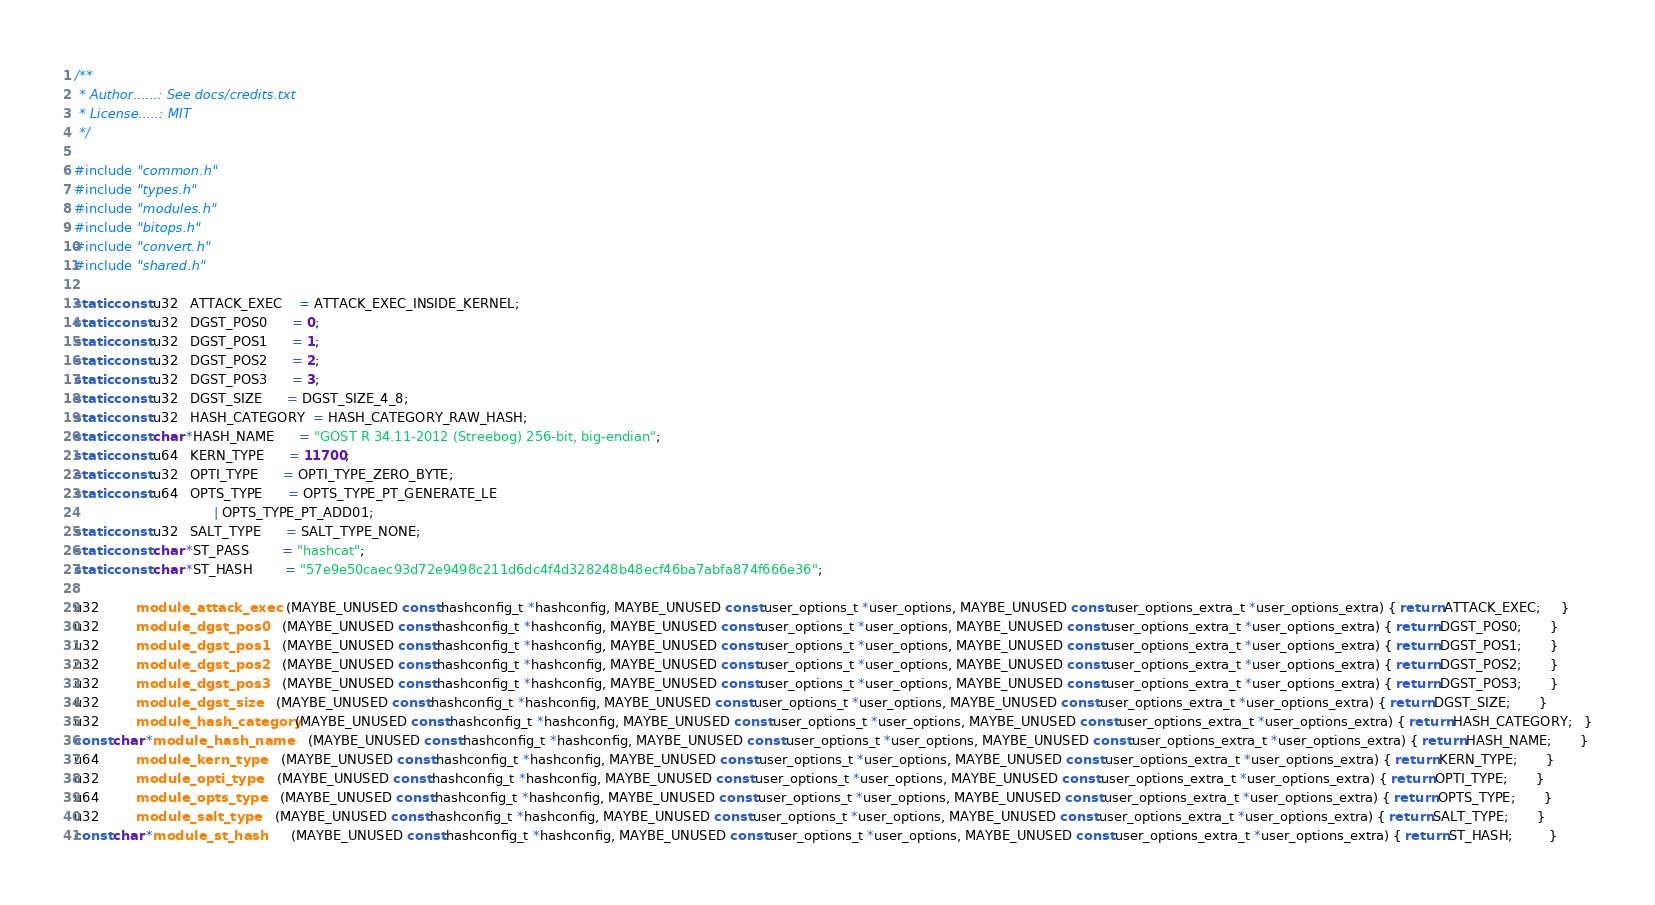Convert code to text. <code><loc_0><loc_0><loc_500><loc_500><_C_>/**
 * Author......: See docs/credits.txt
 * License.....: MIT
 */

#include "common.h"
#include "types.h"
#include "modules.h"
#include "bitops.h"
#include "convert.h"
#include "shared.h"

static const u32   ATTACK_EXEC    = ATTACK_EXEC_INSIDE_KERNEL;
static const u32   DGST_POS0      = 0;
static const u32   DGST_POS1      = 1;
static const u32   DGST_POS2      = 2;
static const u32   DGST_POS3      = 3;
static const u32   DGST_SIZE      = DGST_SIZE_4_8;
static const u32   HASH_CATEGORY  = HASH_CATEGORY_RAW_HASH;
static const char *HASH_NAME      = "GOST R 34.11-2012 (Streebog) 256-bit, big-endian";
static const u64   KERN_TYPE      = 11700;
static const u32   OPTI_TYPE      = OPTI_TYPE_ZERO_BYTE;
static const u64   OPTS_TYPE      = OPTS_TYPE_PT_GENERATE_LE
                                  | OPTS_TYPE_PT_ADD01;
static const u32   SALT_TYPE      = SALT_TYPE_NONE;
static const char *ST_PASS        = "hashcat";
static const char *ST_HASH        = "57e9e50caec93d72e9498c211d6dc4f4d328248b48ecf46ba7abfa874f666e36";

u32         module_attack_exec    (MAYBE_UNUSED const hashconfig_t *hashconfig, MAYBE_UNUSED const user_options_t *user_options, MAYBE_UNUSED const user_options_extra_t *user_options_extra) { return ATTACK_EXEC;     }
u32         module_dgst_pos0      (MAYBE_UNUSED const hashconfig_t *hashconfig, MAYBE_UNUSED const user_options_t *user_options, MAYBE_UNUSED const user_options_extra_t *user_options_extra) { return DGST_POS0;       }
u32         module_dgst_pos1      (MAYBE_UNUSED const hashconfig_t *hashconfig, MAYBE_UNUSED const user_options_t *user_options, MAYBE_UNUSED const user_options_extra_t *user_options_extra) { return DGST_POS1;       }
u32         module_dgst_pos2      (MAYBE_UNUSED const hashconfig_t *hashconfig, MAYBE_UNUSED const user_options_t *user_options, MAYBE_UNUSED const user_options_extra_t *user_options_extra) { return DGST_POS2;       }
u32         module_dgst_pos3      (MAYBE_UNUSED const hashconfig_t *hashconfig, MAYBE_UNUSED const user_options_t *user_options, MAYBE_UNUSED const user_options_extra_t *user_options_extra) { return DGST_POS3;       }
u32         module_dgst_size      (MAYBE_UNUSED const hashconfig_t *hashconfig, MAYBE_UNUSED const user_options_t *user_options, MAYBE_UNUSED const user_options_extra_t *user_options_extra) { return DGST_SIZE;       }
u32         module_hash_category  (MAYBE_UNUSED const hashconfig_t *hashconfig, MAYBE_UNUSED const user_options_t *user_options, MAYBE_UNUSED const user_options_extra_t *user_options_extra) { return HASH_CATEGORY;   }
const char *module_hash_name      (MAYBE_UNUSED const hashconfig_t *hashconfig, MAYBE_UNUSED const user_options_t *user_options, MAYBE_UNUSED const user_options_extra_t *user_options_extra) { return HASH_NAME;       }
u64         module_kern_type      (MAYBE_UNUSED const hashconfig_t *hashconfig, MAYBE_UNUSED const user_options_t *user_options, MAYBE_UNUSED const user_options_extra_t *user_options_extra) { return KERN_TYPE;       }
u32         module_opti_type      (MAYBE_UNUSED const hashconfig_t *hashconfig, MAYBE_UNUSED const user_options_t *user_options, MAYBE_UNUSED const user_options_extra_t *user_options_extra) { return OPTI_TYPE;       }
u64         module_opts_type      (MAYBE_UNUSED const hashconfig_t *hashconfig, MAYBE_UNUSED const user_options_t *user_options, MAYBE_UNUSED const user_options_extra_t *user_options_extra) { return OPTS_TYPE;       }
u32         module_salt_type      (MAYBE_UNUSED const hashconfig_t *hashconfig, MAYBE_UNUSED const user_options_t *user_options, MAYBE_UNUSED const user_options_extra_t *user_options_extra) { return SALT_TYPE;       }
const char *module_st_hash        (MAYBE_UNUSED const hashconfig_t *hashconfig, MAYBE_UNUSED const user_options_t *user_options, MAYBE_UNUSED const user_options_extra_t *user_options_extra) { return ST_HASH;         }</code> 